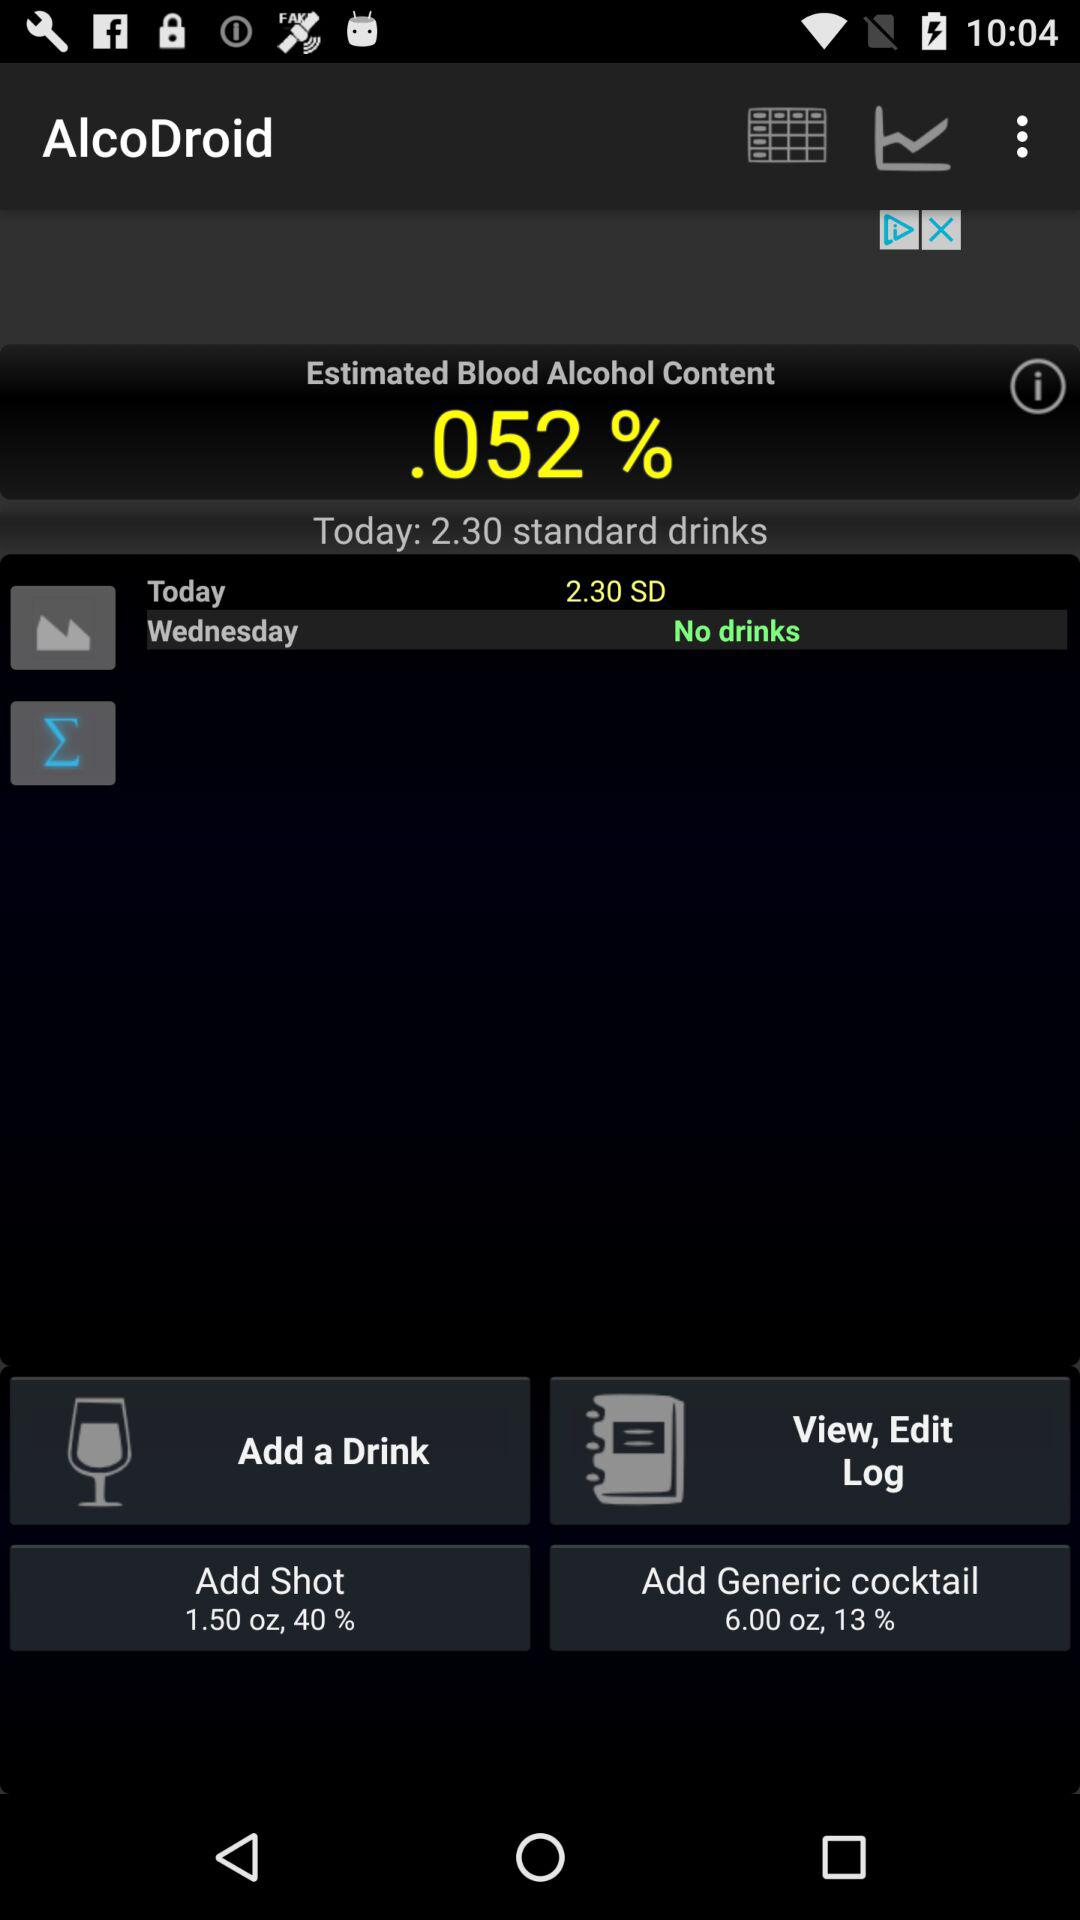What is the estimated blood alcohol content percentage? The estimated blood alcohol content is 0.052%. 